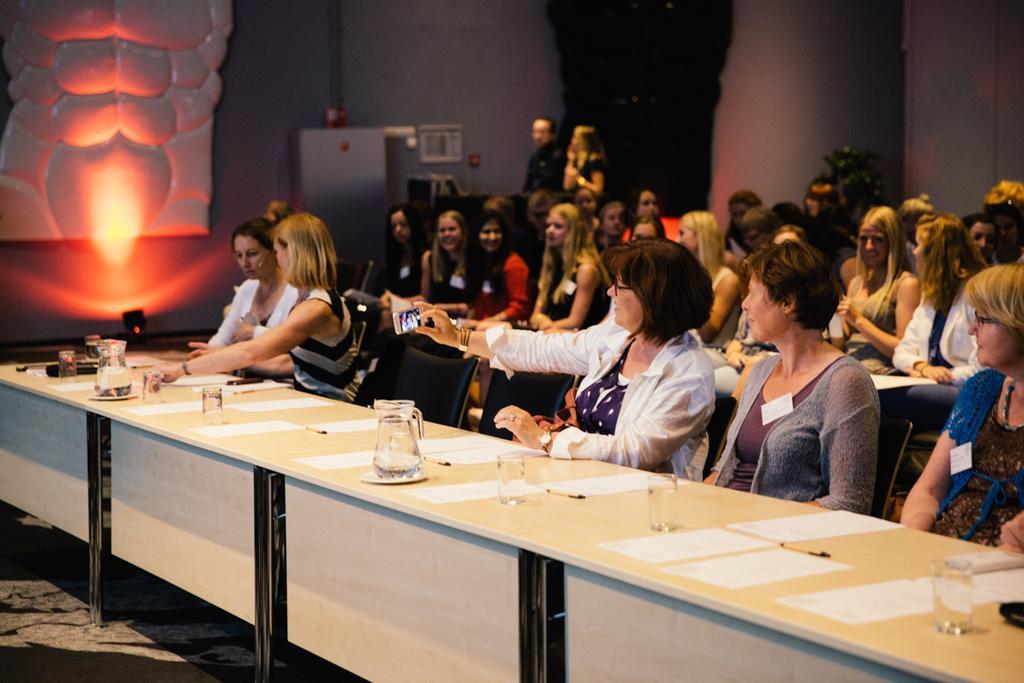Describe this image in one or two sentences. In this image we can see many people are sitting on the chairs near the table. We can see a jar, glass, papers and pen on the table. 